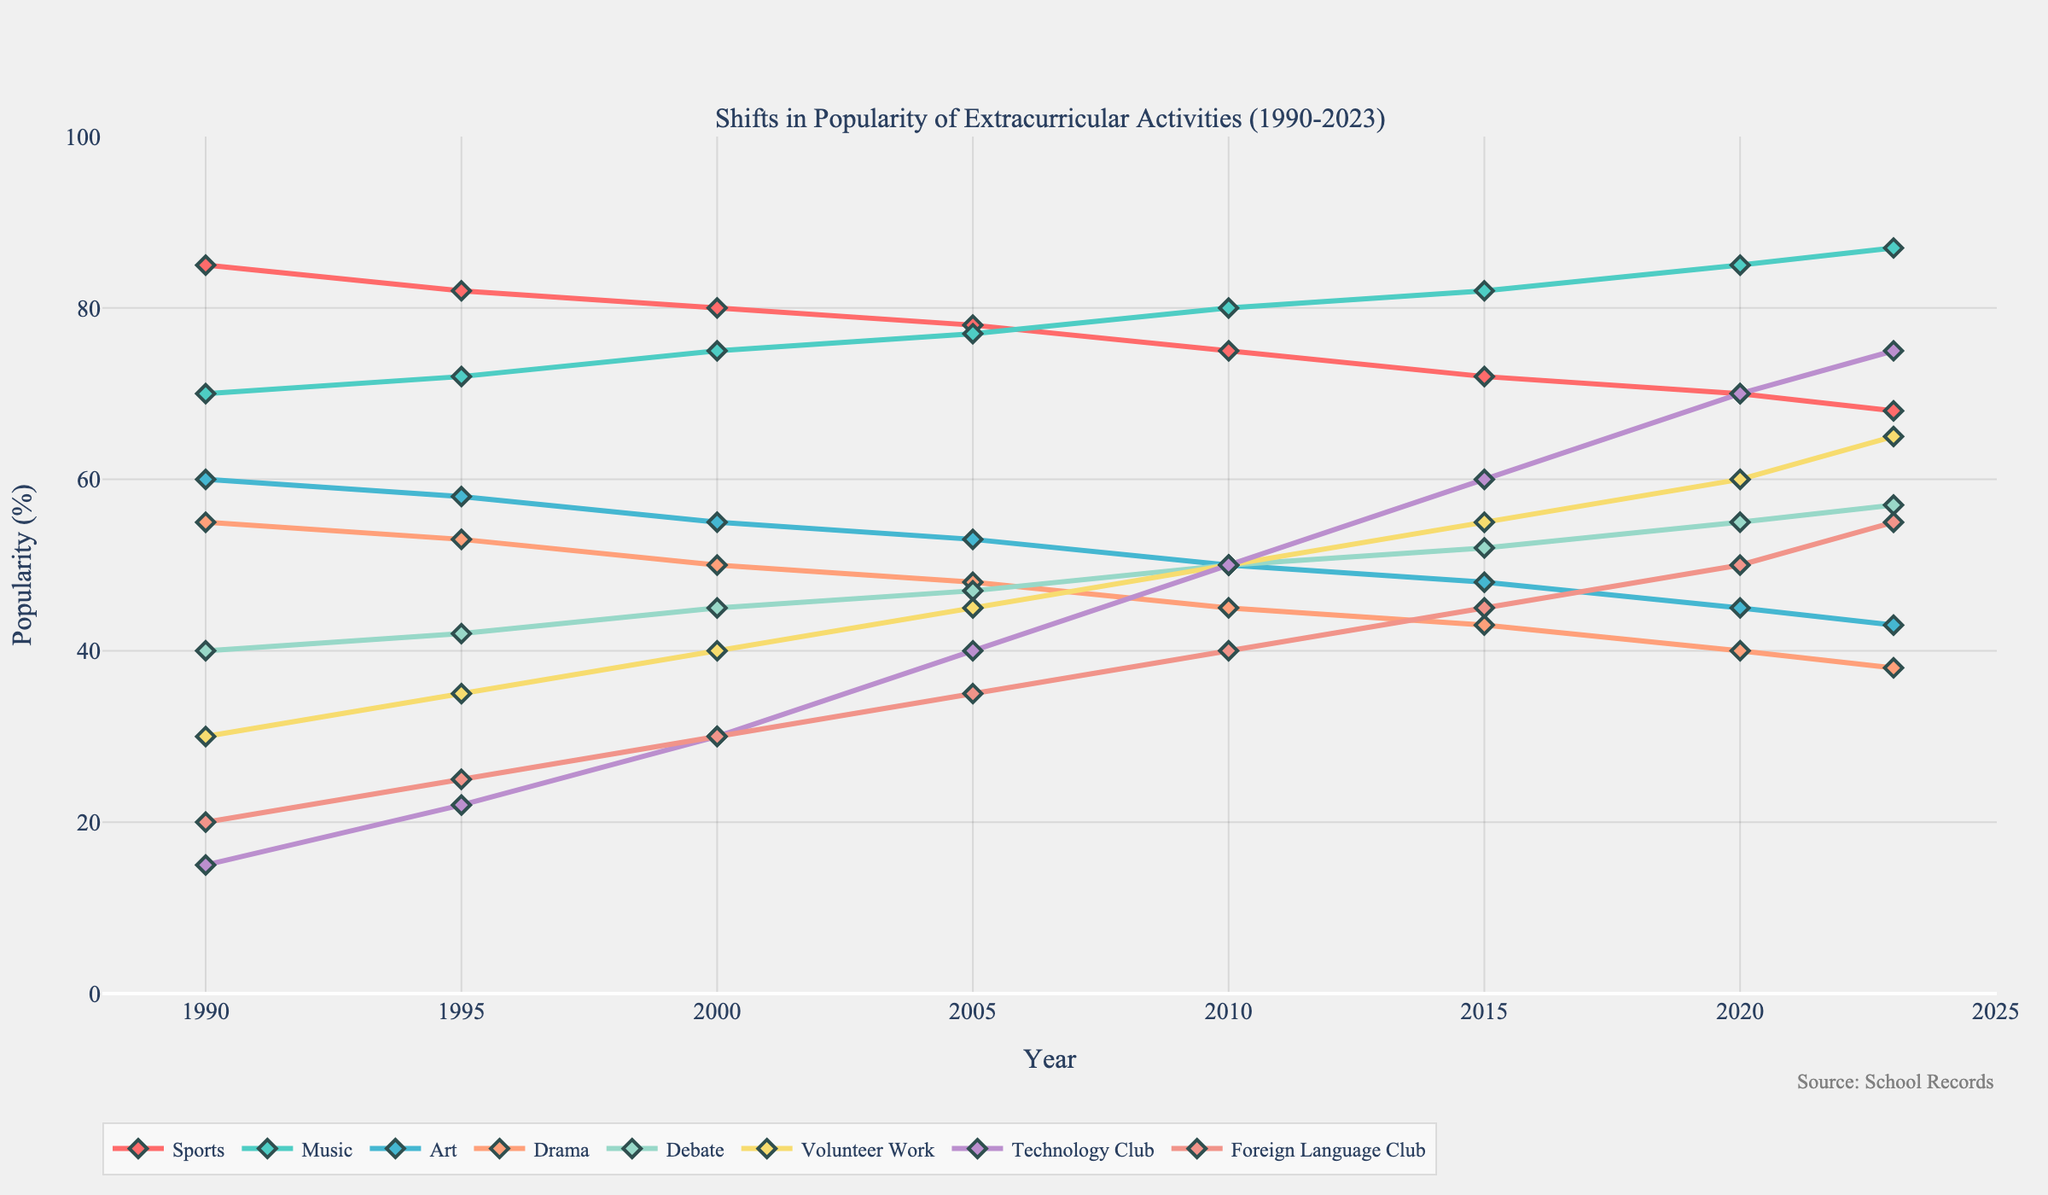What is the difference in the popularity of Volunteer Work between 1990 and 2023? In 1990, the popularity of Volunteer Work was 30%. In 2023, it was 65%. The difference can be calculated as 65% - 30% = 35%.
Answer: 35% Which extracurricular activity had the highest popularity in 2023? By looking at the figure, Music had the highest popularity in 2023 with 87%.
Answer: Music What was the trend of Technology Club participation from 1990 to 2023? Technology Club shows a steady increase in popularity from 15% in 1990 to 75% in 2023.
Answer: Increasing In which year did Foreign Language Club first surpass a 30% popularity rate? Foreign Language Club surpassed 30% in 2000 with a 30% popularity rate and continued to increase thereafter.
Answer: 2000 Were there any years when Drama was more popular than Art? By comparing the lines for Drama and Art, Drama was never more popular than Art from 1990 to 2023.
Answer: No What was the average popularity of Sports from 1990 to 2023? The popularity of Sports from 1990 to 2023 is [85, 82, 80, 78, 75, 72, 70, 68]. To find the average, sum them and divide by the number of data points: (85 + 82 + 80 + 78 + 75 + 72 + 70 + 68) / 8 = 610 / 8 = 76.25%.
Answer: 76.25% How did the popularity of Debate change between 1990 and 2023, and what might this trend indicate? Debate popularity increased from 40% in 1990 to 57% in 2023. This steady increase may indicate a growing interest and valuing of debate skills over time.
Answer: Increased Which activity saw the largest increase in popularity from 1990 to 2023? Comparing the initial and final years, Technology Club saw the largest increase from 15% in 1990 to 75% in 2023, an increase of 60%.
Answer: Technology Club What is the difference in popularity between the most and least popular extracurricular activities in 2020? In 2020, the most popular was Music at 85%, and the least was Drama at 40%. The difference is 85% - 40% = 45%.
Answer: 45% Which activity showed a steady increase in popularity without a single decline from 1990 to 2023? Technology Club showed a steady increase every year from 1990 (15%) to 2023 (75%) without any declines.
Answer: Technology Club 